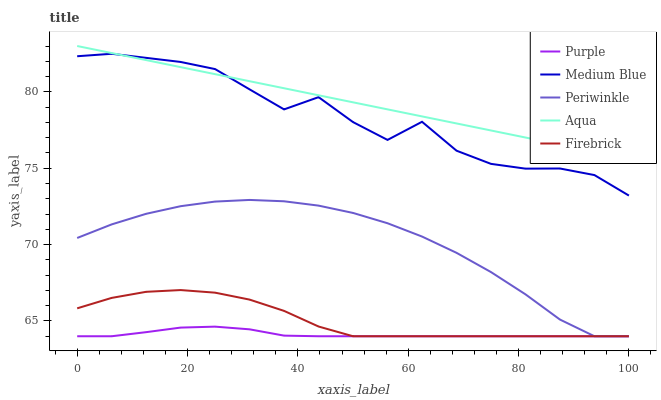Does Purple have the minimum area under the curve?
Answer yes or no. Yes. Does Aqua have the maximum area under the curve?
Answer yes or no. Yes. Does Periwinkle have the minimum area under the curve?
Answer yes or no. No. Does Periwinkle have the maximum area under the curve?
Answer yes or no. No. Is Aqua the smoothest?
Answer yes or no. Yes. Is Medium Blue the roughest?
Answer yes or no. Yes. Is Periwinkle the smoothest?
Answer yes or no. No. Is Periwinkle the roughest?
Answer yes or no. No. Does Purple have the lowest value?
Answer yes or no. Yes. Does Aqua have the lowest value?
Answer yes or no. No. Does Aqua have the highest value?
Answer yes or no. Yes. Does Periwinkle have the highest value?
Answer yes or no. No. Is Periwinkle less than Aqua?
Answer yes or no. Yes. Is Medium Blue greater than Firebrick?
Answer yes or no. Yes. Does Firebrick intersect Periwinkle?
Answer yes or no. Yes. Is Firebrick less than Periwinkle?
Answer yes or no. No. Is Firebrick greater than Periwinkle?
Answer yes or no. No. Does Periwinkle intersect Aqua?
Answer yes or no. No. 